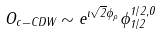<formula> <loc_0><loc_0><loc_500><loc_500>O _ { c - C D W } \sim e ^ { \imath \sqrt { 2 } \phi _ { \rho } } \phi ^ { 1 / 2 , 0 } _ { 1 / 2 }</formula> 